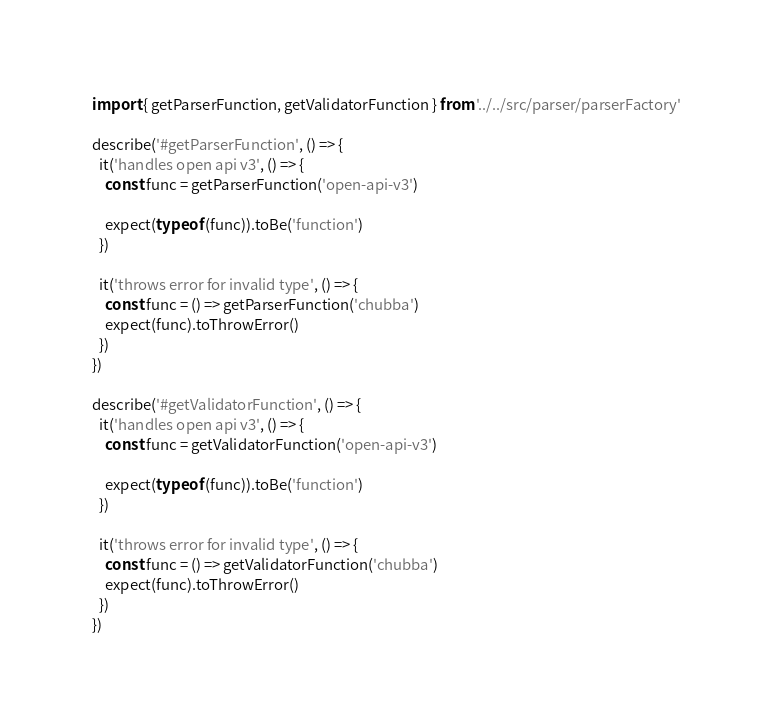<code> <loc_0><loc_0><loc_500><loc_500><_JavaScript_>import { getParserFunction, getValidatorFunction } from '../../src/parser/parserFactory'

describe('#getParserFunction', () => {
  it('handles open api v3', () => {
    const func = getParserFunction('open-api-v3')

    expect(typeof (func)).toBe('function')
  })

  it('throws error for invalid type', () => {
    const func = () => getParserFunction('chubba')
    expect(func).toThrowError()
  })
})

describe('#getValidatorFunction', () => {
  it('handles open api v3', () => {
    const func = getValidatorFunction('open-api-v3')

    expect(typeof (func)).toBe('function')
  })

  it('throws error for invalid type', () => {
    const func = () => getValidatorFunction('chubba')
    expect(func).toThrowError()
  })
})
</code> 